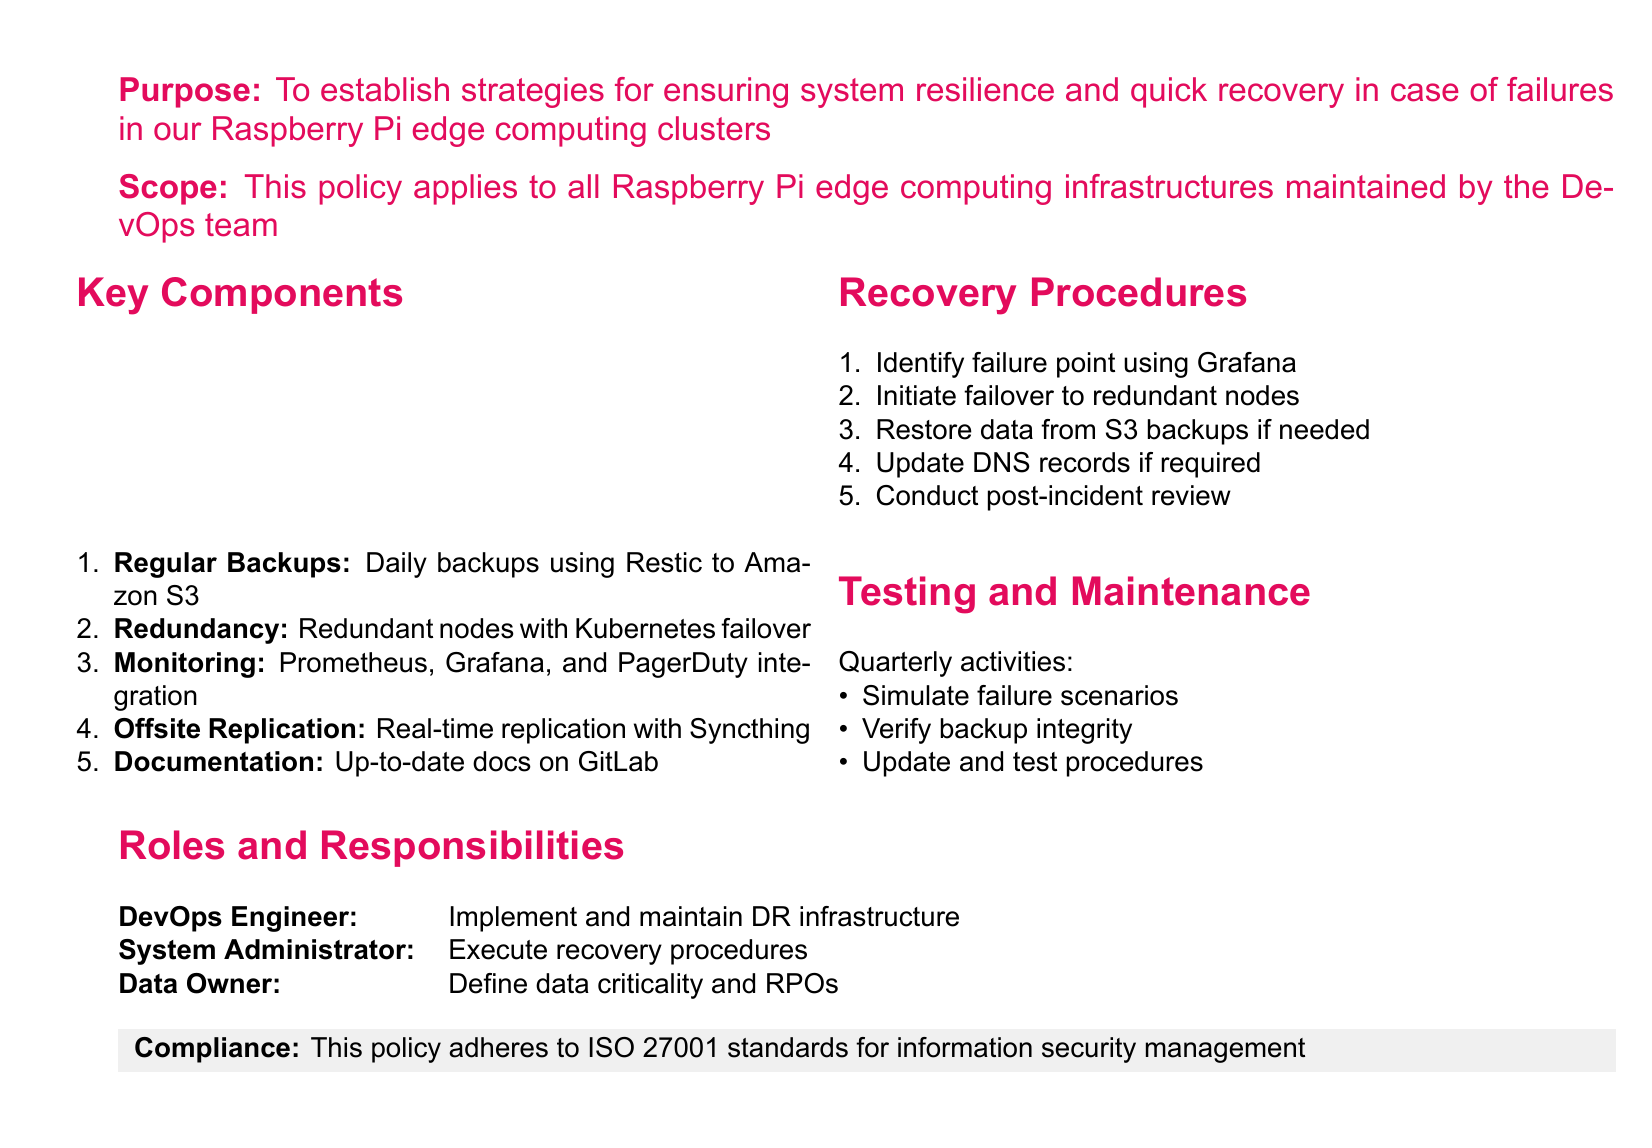What is the purpose of the policy? The purpose is stated at the beginning of the document, which outlines strategies for ensuring system resilience and quick recovery in case of failures in Raspberry Pi edge computing clusters.
Answer: Establish strategies for ensuring system resilience and quick recovery Who does the scope of the policy apply to? The scope section specifies the applicability of the policy, stating it applies to all infrastructures.
Answer: All Raspberry Pi edge computing infrastructures maintained by the DevOps team What is the first key component listed? The first key component listed in the Key Components section is Regular Backups.
Answer: Regular Backups How often are backups performed? The document explicitly states the frequency of backups in the key components section.
Answer: Daily What monitoring tools are mentioned in the policy? The policy lists specific tools used for monitoring in the Key Components section.
Answer: Prometheus, Grafana, and PagerDuty What action should be taken after identifying a failure point? The Recovery Procedures section outlines the initial steps to be taken, emphasizing actions after identifying issues.
Answer: Initiate failover to redundant nodes How frequently are testing activities conducted? The document mentions the schedule for testing activities in the Testing and Maintenance section.
Answer: Quarterly Who executes the recovery procedures? The Roles and Responsibilities section specifies the individual responsible for executing these procedures.
Answer: System Administrator In what standards does the policy ensure compliance? The final section about compliance specifies the standard to which the policy adheres.
Answer: ISO 27001 